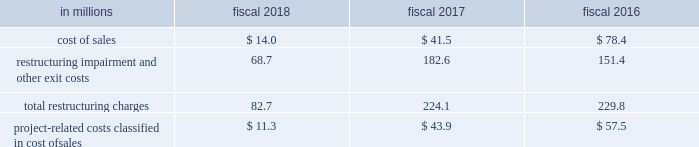Reduced administrative expense .
In connection with this project , we eliminated 749 positions .
We incurred $ 54.7 million of net expenses , most of which was cash .
We recorded $ 0.4 million of restructuring charges relating to this action in fiscal 2018 , restructuring charges were reduced by $ 0.4 million in fiscal 2017 , and we incurred $ 54.7 million of restructuring charges in fiscal 2016 .
This action was completed in fiscal 2018 .
In fiscal 2015 , we announced project century ( century ) which initially involved a review of our north american manufacturing and distribution network to streamline operations and identify potential capacity reductions .
In fiscal 2016 , we broadened the scope of century to identify opportunities to streamline our supply chain outside of north america .
As part of century , in the second quarter of fiscal 2016 , we approved a restructuring plan to close manufacturing facilities in our europe & australia segment supply chain located in berwick , united kingdom and east tamaki , new zealand .
These actions affected 287 positions and we incurred $ 31.8 million of net expenses related to these actions , of which $ 12 million was cash .
We recorded $ 1.8 million of restructuring charges relating to these actions in fiscal 2017 and $ 30.0 million in fiscal 2016 .
These actions were completed in fiscal 2017 .
As part of century , in the first quarter of fiscal 2016 , we approved a restructuring plan to close our west chicago , illinois cereal and dry dinner manufacturing plant in our north america retail segment supply chain .
This action affected 484 positions , and we incurred $ 109.3 million of net expenses relating to this action , of which $ 21 million was cash .
We recorded $ 6.9 million of restructuring charges relating to this action in fiscal 2018 , $ 23.2 million in fiscal 2017 and $ 79.2 million in fiscal 2016 .
This action was completed in fiscal 2018 .
As part of century , in the first quarter of fiscal 2016 , we approved a restructuring plan to close our joplin , missouri snacks plant in our north america retail segment supply chain .
This action affected 125 positions , and we incurred $ 8.0 million of net expenses relating to this action , of which less than $ 1 million was cash .
We recorded $ 1.4 million of restructuring charges relating to this action in fiscal 2018 , $ 0.3 million in fiscal 2017 , and $ 6.3 million in fiscal 2016 .
This action was completed in fiscal 2018 .
We paid cash related to restructuring initiatives of $ 53.6 million in fiscal 2018 , $ 107.8 million in fiscal 2017 , and $ 122.6 million in fiscal 2016 .
In addition to restructuring charges , we expect to incur approximately $ 130 million of project-related costs , which will be recorded in cost of sales , all of which will be cash .
We recorded project-related costs in cost of sales of $ 11.3 million in fiscal 2018 , $ 43.9 million in fiscal 2017 , and $ 57.5 million in fiscal 2016 .
We paid cash for project-related costs of $ 10.9 million in fiscal 2018 , $ 46.9 million in fiscal 2017 , and $ 54.5 million in fiscal 2016 .
We expect these activities to be completed in fiscal 2019 .
Restructuring charges and project-related costs are classified in our consolidated statements of earnings as follows: .

What is the total amount paid in cash related to restructuring initiatives for the last three years? 
Computations: ((122.6 + 107.8) + 53.6)
Answer: 284.0. 